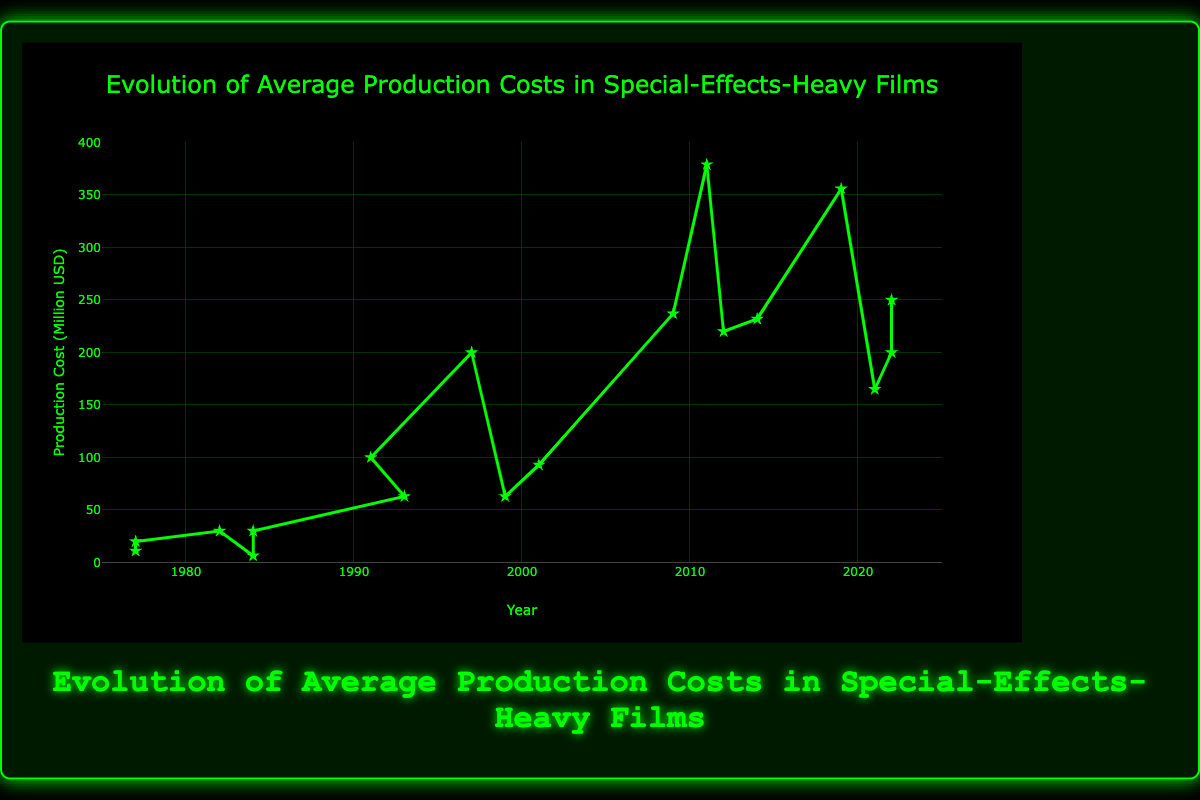Which era had the highest average production cost for special-effects-heavy films? By looking at the y-axis and identifying the highest point on the plot, we see that the peak is reached in the 2010s era. This is justified by the data point for "Pirates of the Caribbean: On Stranger Tides (2011)" which had a production cost of $379 million.
Answer: 2010s How does the production cost of "Terminator 2: Judgment Day (1991)" compare to "The Matrix (1999)"? The production cost for "Terminator 2: Judgment Day (1991)" is $100 million, while for "The Matrix (1999)" it is $63 million. By comparing these values, "Terminator 2: Judgment Day" had a higher production cost.
Answer: Terminator 2: Judgment Day was higher What's the average increase in production costs per decade from the 1980s to the 2000s? To find the average increase, first, calculate the differences: $100 million for the 1990s from $30 million in the 1980s ($70 million increase). For the 2000s, let's use $237 million from "Avatar (2009)" and $200 million from "Titanic (1997)", we can see the increase is $137 million. The average increase is then ($70 million + $137 million)/2=$103.5 million.
Answer: $103.5 million How does the production cost of "The Lord of the Rings: The Fellowship of the Ring (2001)" compare to "The Avengers (2012)"? "The Lord of the Rings: The Fellowship of the Ring (2001)" had a production cost of $93 million whereas "The Avengers (2012)" had a production cost of $220 million. By comparing these, "The Avengers (2012)" had a much higher production cost.
Answer: The Avengers was higher What is the total production cost for films in the 2020s era shown in the chart? The films in the 2020s era are "Dune (2021)" at $165 million, "The Batman (2022)" at $200 million, and "Avatar: The Way of Water (2022)" at $250 million. Adding these together, $165 million + $200 million + $250 million = $615 million.
Answer: $615 million From the 1970s to the 2020s, which decade saw the most significant increase in production costs? First, identify the differences in production costs for key films in each decade: $20 million in the 1970s to $30 million in the 1980s ($10 million increase), $100 million in the 1990s ($70 million increase), $237 million in the 2000s ($137 million increase), and $379 million in the 2010s ($142 million increase). The most significant increase occurred between the 2000s and 2010s with a dramatic jump.
Answer: 2010s Which film had the highest production cost according to the plot? By examining the y-axis and the highest point in the plot, the film with the highest production cost is "Pirates of the Caribbean: On Stranger Tides (2011)" at $379 million.
Answer: Pirates of the Caribbean: On Stranger Tides Which two movies from different decades had similar production costs, according to the plot? By examining the plot for similar y-axis values, "The Matrix (1999)" and "Jurassic Park (1993)" both had production costs close to $63 million.
Answer: The Matrix and Jurassic Park 